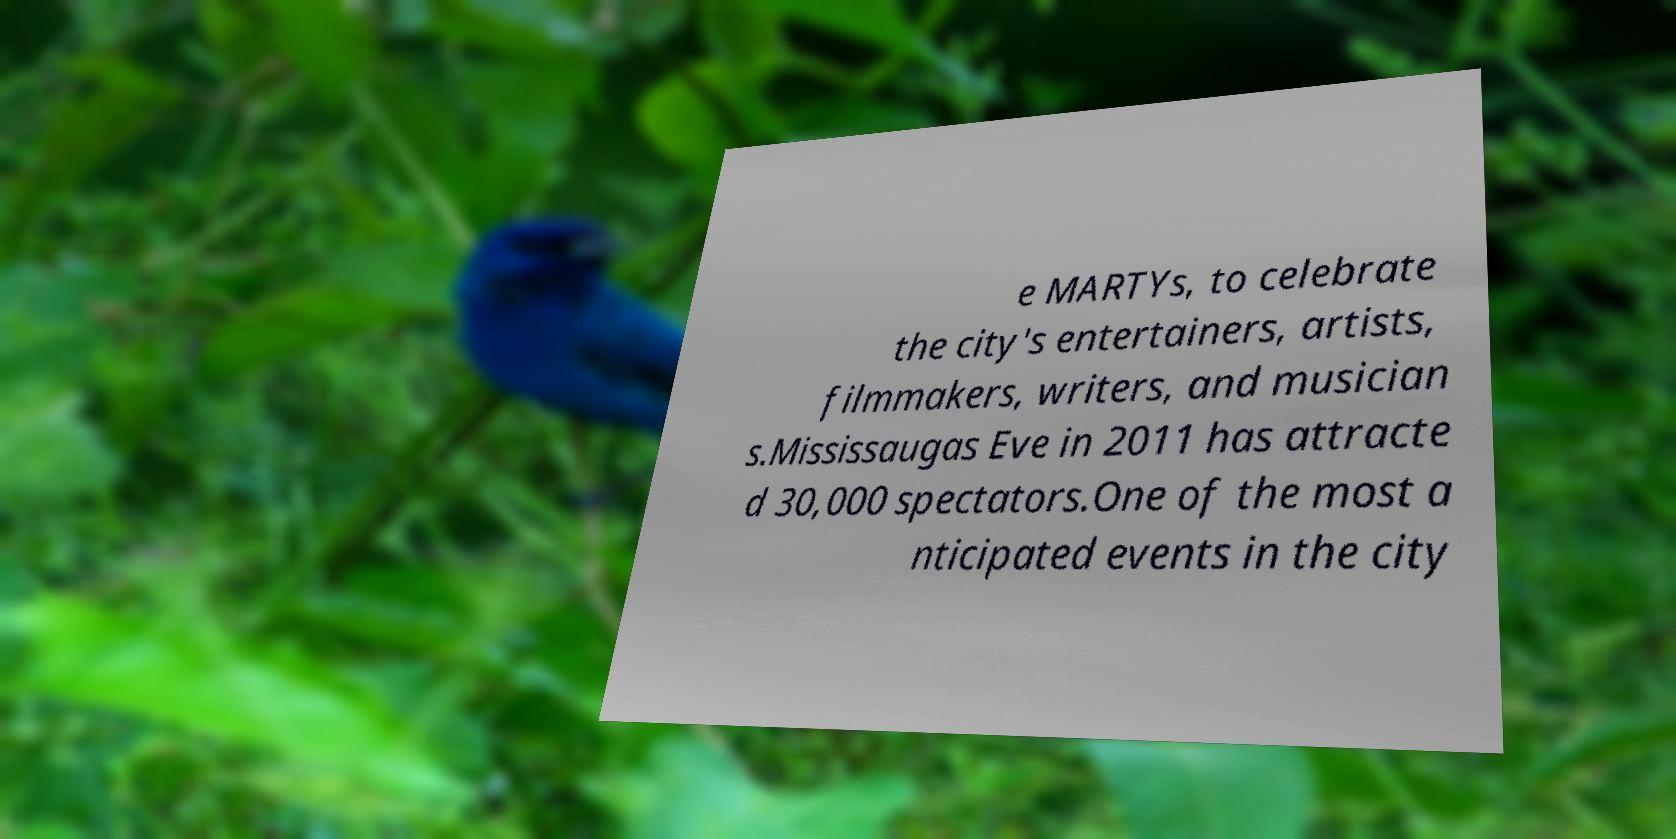There's text embedded in this image that I need extracted. Can you transcribe it verbatim? e MARTYs, to celebrate the city's entertainers, artists, filmmakers, writers, and musician s.Mississaugas Eve in 2011 has attracte d 30,000 spectators.One of the most a nticipated events in the city 